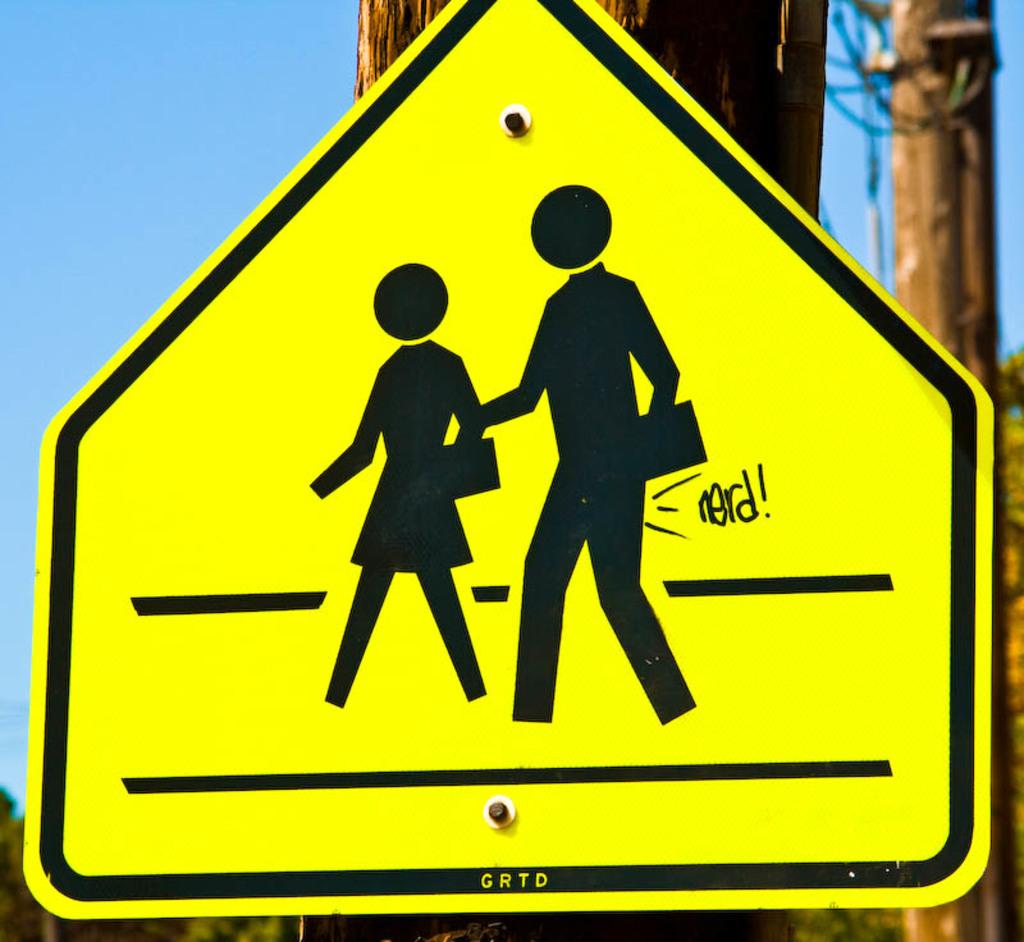What word is graffiti-ed on the sign?
Your response must be concise. Nerd. 